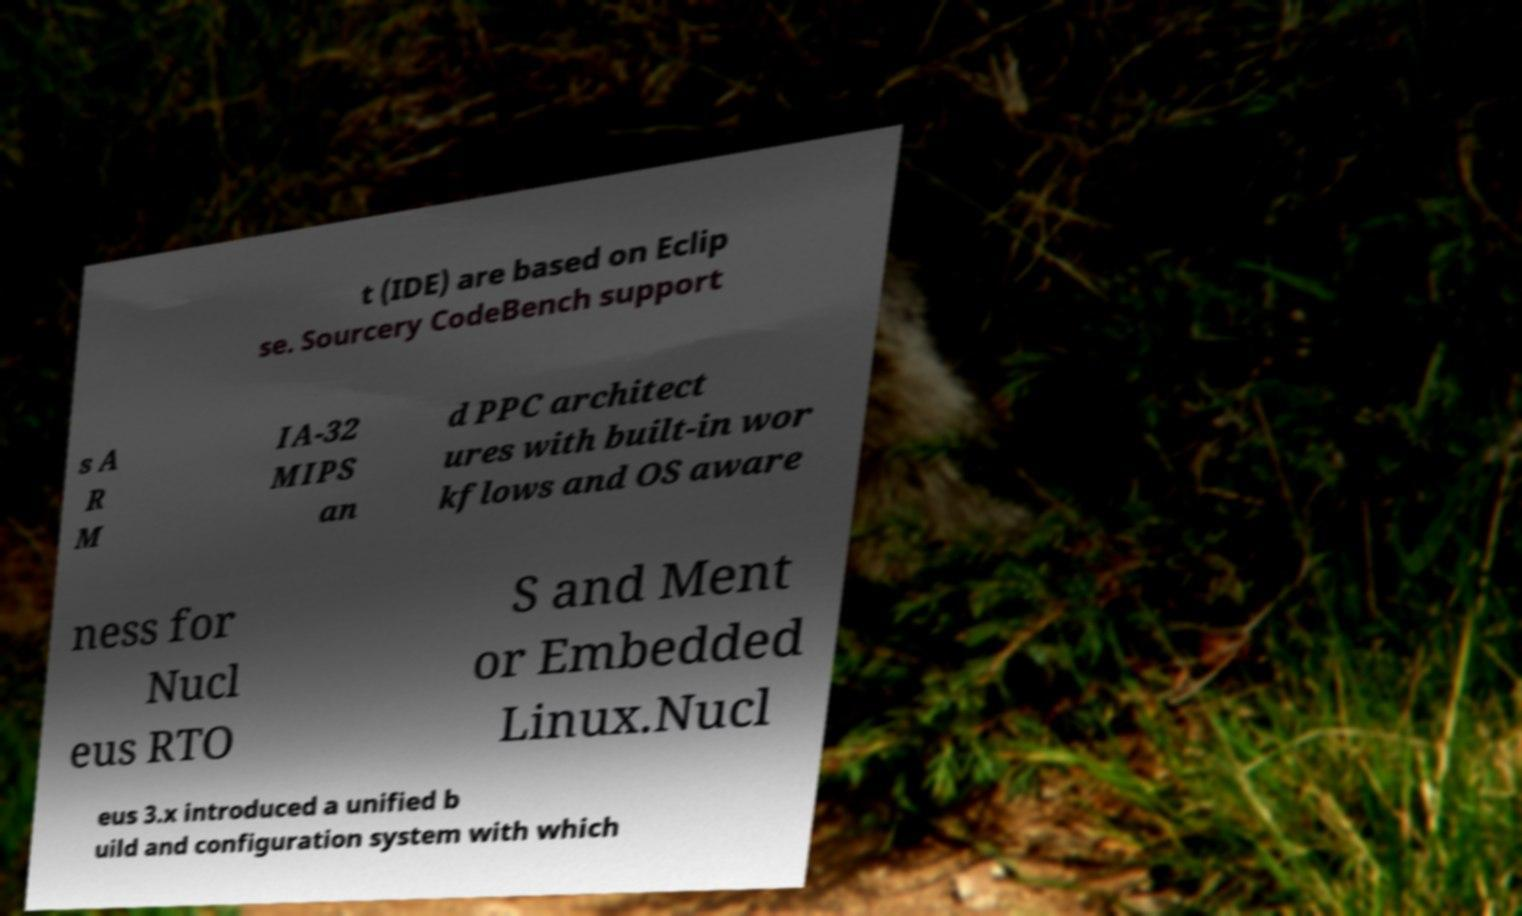Could you extract and type out the text from this image? t (IDE) are based on Eclip se. Sourcery CodeBench support s A R M IA-32 MIPS an d PPC architect ures with built-in wor kflows and OS aware ness for Nucl eus RTO S and Ment or Embedded Linux.Nucl eus 3.x introduced a unified b uild and configuration system with which 